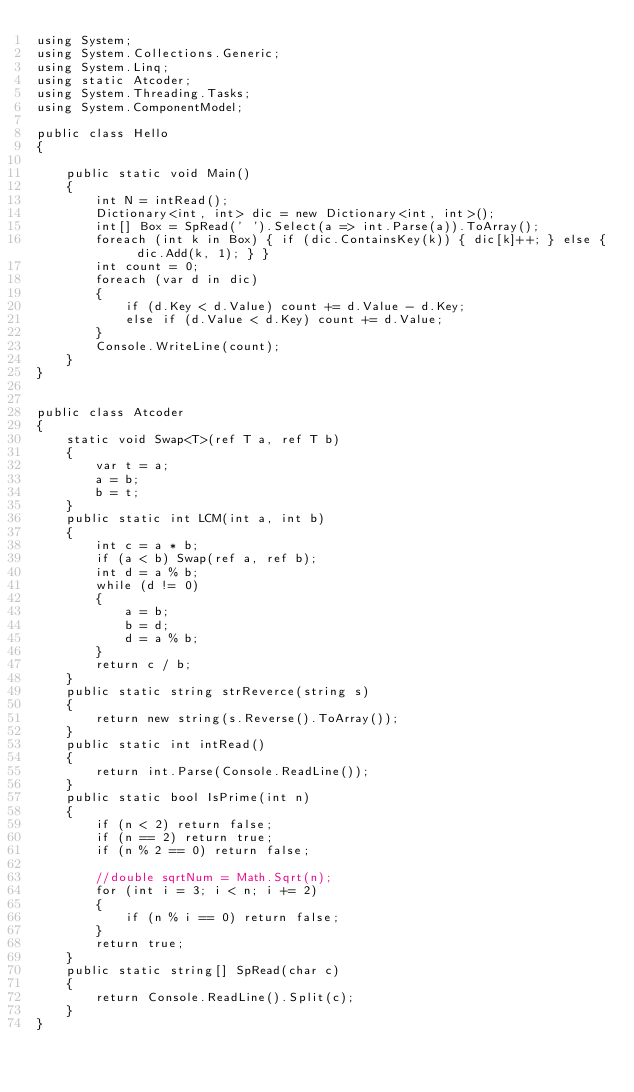Convert code to text. <code><loc_0><loc_0><loc_500><loc_500><_C#_>using System;
using System.Collections.Generic;
using System.Linq;
using static Atcoder;
using System.Threading.Tasks;
using System.ComponentModel;

public class Hello
{

    public static void Main()
    {
        int N = intRead();
        Dictionary<int, int> dic = new Dictionary<int, int>();
        int[] Box = SpRead(' ').Select(a => int.Parse(a)).ToArray();
        foreach (int k in Box) { if (dic.ContainsKey(k)) { dic[k]++; } else { dic.Add(k, 1); } }
        int count = 0;
        foreach (var d in dic)
        {
            if (d.Key < d.Value) count += d.Value - d.Key;
            else if (d.Value < d.Key) count += d.Value;
        }
        Console.WriteLine(count);
    }
}


public class Atcoder
{
    static void Swap<T>(ref T a, ref T b)
    {
        var t = a;
        a = b;
        b = t;
    }
    public static int LCM(int a, int b)
    {
        int c = a * b;
        if (a < b) Swap(ref a, ref b);
        int d = a % b;
        while (d != 0)
        {
            a = b;
            b = d;
            d = a % b;
        }
        return c / b;
    }
    public static string strReverce(string s)
    {
        return new string(s.Reverse().ToArray());
    }
    public static int intRead()
    {
        return int.Parse(Console.ReadLine());
    }
    public static bool IsPrime(int n)
    {
        if (n < 2) return false;
        if (n == 2) return true;
        if (n % 2 == 0) return false;

        //double sqrtNum = Math.Sqrt(n);
        for (int i = 3; i < n; i += 2)
        {
            if (n % i == 0) return false;
        }
        return true;
    }
    public static string[] SpRead(char c)
    {
        return Console.ReadLine().Split(c);
    }
}
</code> 